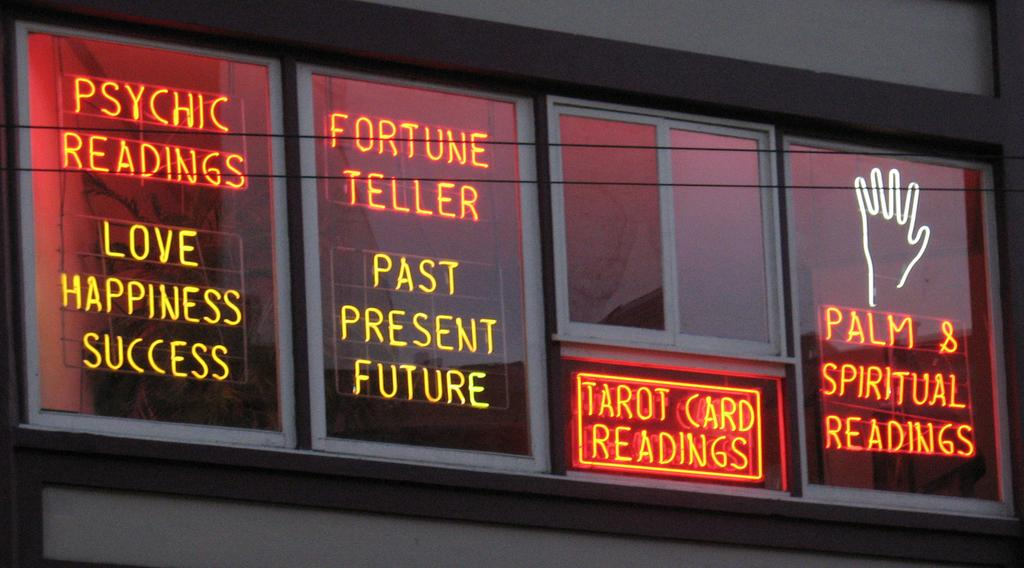Provide a one-sentence caption for the provided image. A palm reader with a neon sign that says everything they offer. 